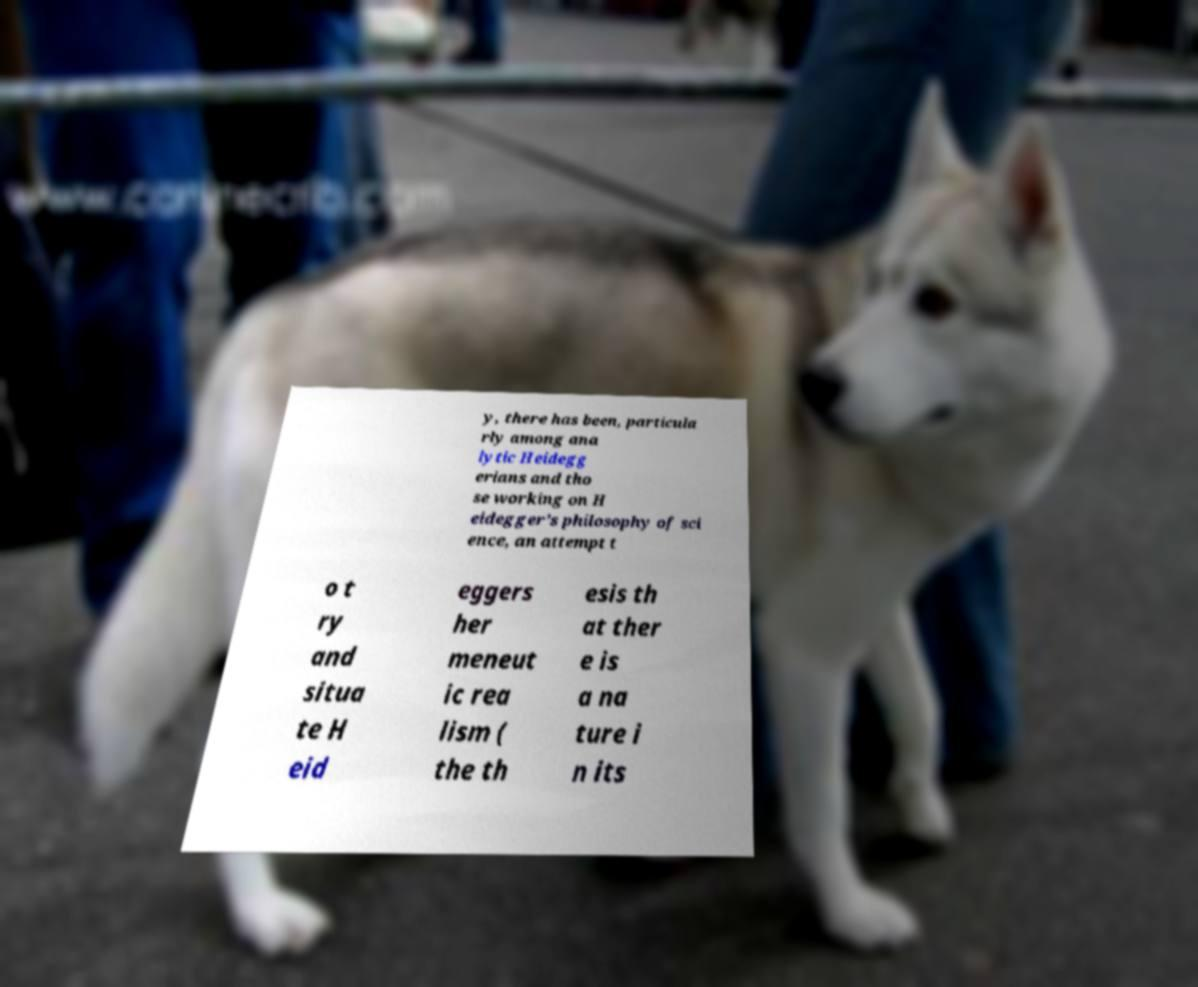What messages or text are displayed in this image? I need them in a readable, typed format. y, there has been, particula rly among ana lytic Heidegg erians and tho se working on H eidegger’s philosophy of sci ence, an attempt t o t ry and situa te H eid eggers her meneut ic rea lism ( the th esis th at ther e is a na ture i n its 